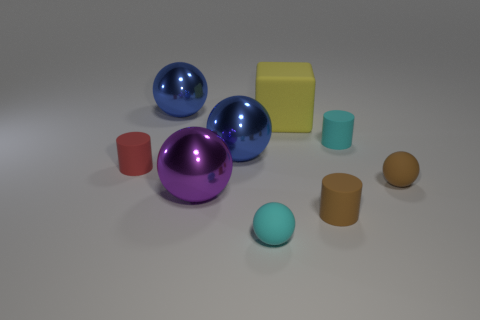Do the cylinder that is in front of the red rubber cylinder and the tiny ball that is behind the large purple metallic sphere have the same color?
Offer a terse response. Yes. How many other objects are there of the same size as the red thing?
Keep it short and to the point. 4. Does the red rubber cylinder have the same size as the yellow rubber object?
Your answer should be very brief. No. There is a large object that is in front of the red thing; what is its color?
Your response must be concise. Purple. What is the size of the yellow cube that is made of the same material as the small brown sphere?
Make the answer very short. Large. Does the yellow rubber thing have the same size as the sphere to the left of the purple shiny sphere?
Provide a succinct answer. Yes. What material is the blue sphere that is in front of the large yellow matte object?
Offer a terse response. Metal. There is a blue shiny object that is in front of the yellow block; what number of large yellow objects are on the left side of it?
Offer a terse response. 0. Are there any other big purple objects that have the same shape as the big purple object?
Provide a succinct answer. No. Do the rubber cylinder behind the red cylinder and the blue ball that is behind the rubber cube have the same size?
Give a very brief answer. No. 